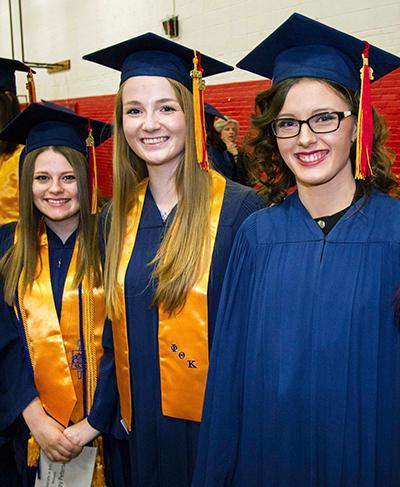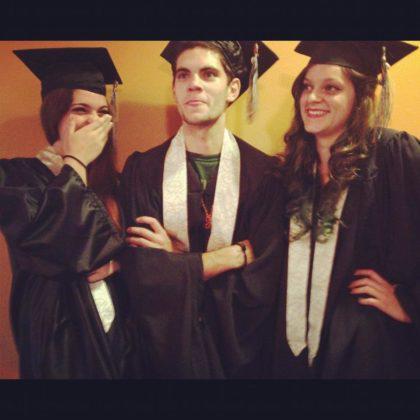The first image is the image on the left, the second image is the image on the right. Analyze the images presented: Is the assertion "There are 2 people wearing graduation caps in the image on the right." valid? Answer yes or no. No. The first image is the image on the left, the second image is the image on the right. For the images displayed, is the sentence "The grads are wearing green around their necks." factually correct? Answer yes or no. No. 